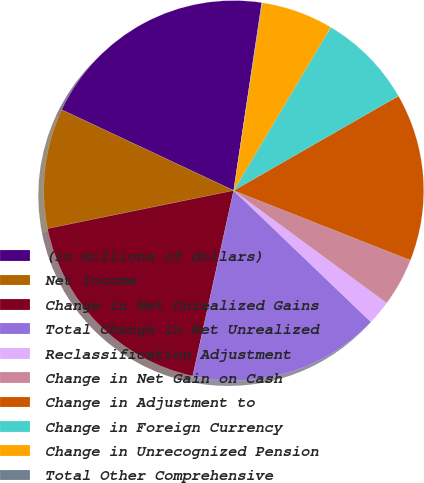<chart> <loc_0><loc_0><loc_500><loc_500><pie_chart><fcel>(in millions of dollars)<fcel>Net Income<fcel>Change in Net Unrealized Gains<fcel>Total Change in Net Unrealized<fcel>Reclassification Adjustment<fcel>Change in Net Gain on Cash<fcel>Change in Adjustment to<fcel>Change in Foreign Currency<fcel>Change in Unrecognized Pension<fcel>Total Other Comprehensive<nl><fcel>20.37%<fcel>10.2%<fcel>18.33%<fcel>16.3%<fcel>2.07%<fcel>4.11%<fcel>14.27%<fcel>8.17%<fcel>6.14%<fcel>0.04%<nl></chart> 